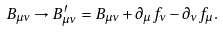<formula> <loc_0><loc_0><loc_500><loc_500>B _ { \mu \nu } \rightarrow B ^ { \prime } _ { \mu \nu } = B _ { \mu \nu } + \partial _ { \mu } f _ { \nu } - \partial _ { \nu } f _ { \mu } .</formula> 